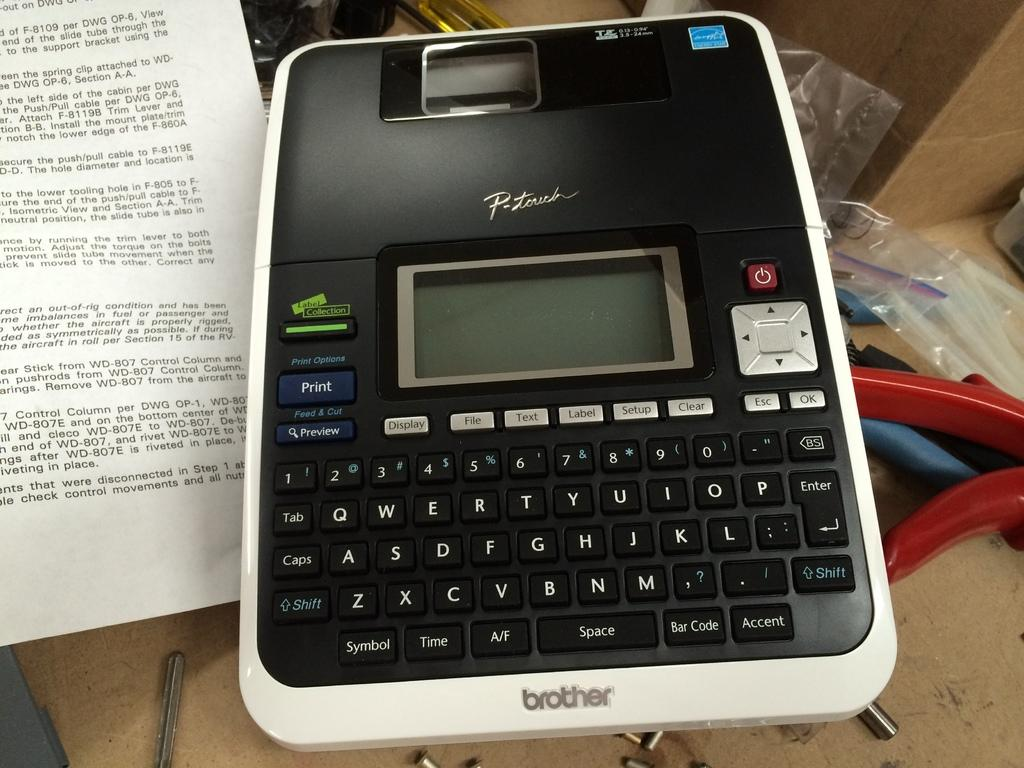<image>
Write a terse but informative summary of the picture. An old brother word processor is shown next to a sheet of manual. 